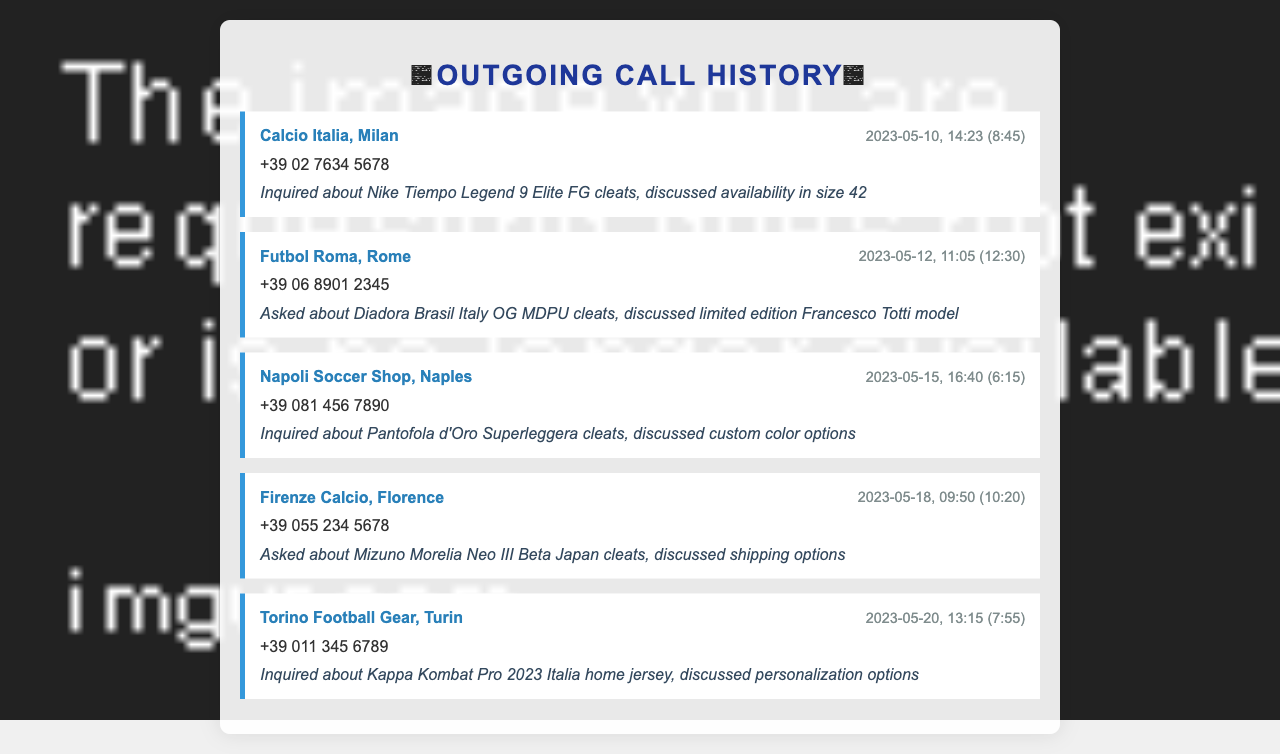What is the name of the first store called? The first store listed in the document is Calcio Italia, Milan.
Answer: Calcio Italia, Milan What date was the call made to Napoli Soccer Shop? The call to Napoli Soccer Shop was made on May 15, 2023.
Answer: 2023-05-15 How long was the call to Futbol Roma? The call to Futbol Roma lasted for 12 minutes and 30 seconds.
Answer: 12:30 What specific model was inquired about at Calcio Italia? The inquiry at Calcio Italia was about the Nike Tiempo Legend 9 Elite FG cleats.
Answer: Nike Tiempo Legend 9 Elite FG Which store discussed personalization options? Torino Football Gear discussed personalization options for the jersey.
Answer: Torino Football Gear What color options were discussed for Pantofola d'Oro cleats? The discussion for Pantofola d'Oro cleats included custom color options.
Answer: Custom color options How many calls were made regarding Mizuno cleats? There was one call made regarding Mizuno Morelia Neo III Beta Japan cleats.
Answer: One call What was the topic of discussion during the call to Firenze Calcio? The discussion during the call to Firenze Calcio was about shipping options.
Answer: Shipping options 